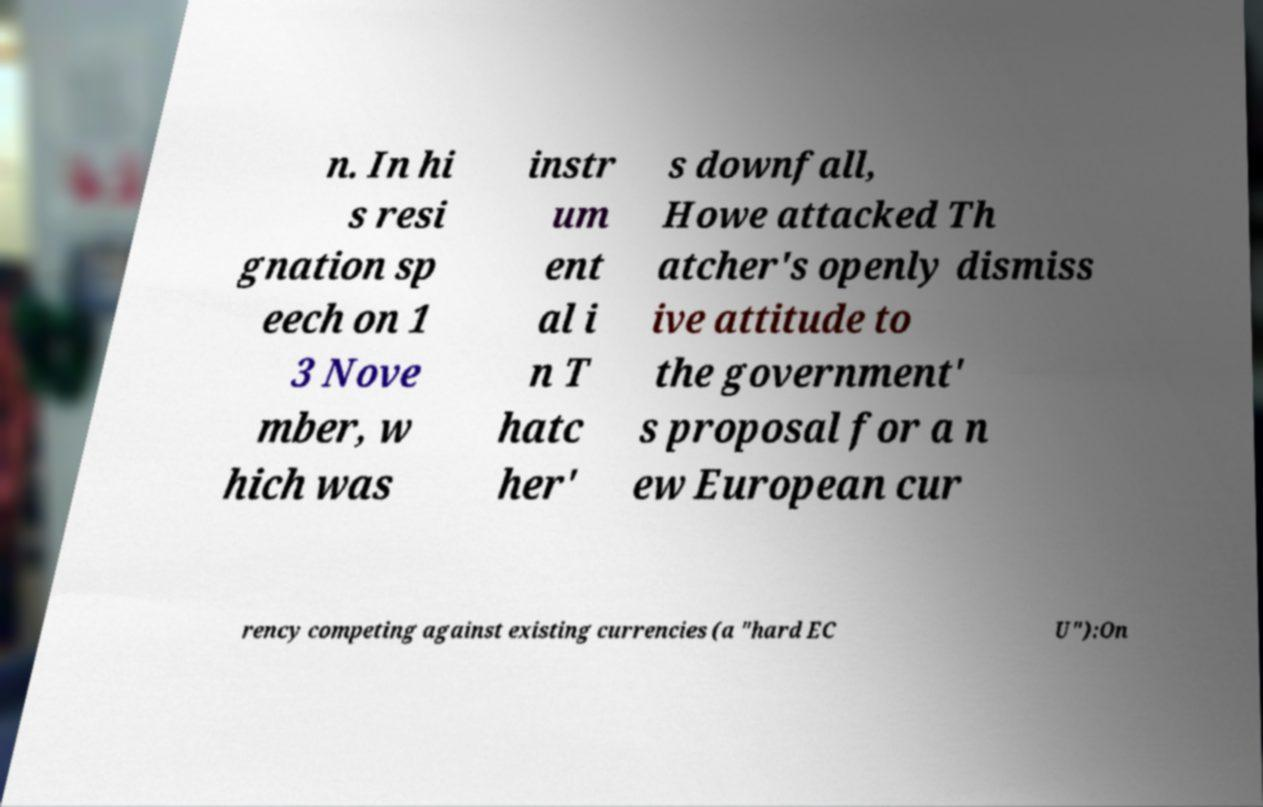For documentation purposes, I need the text within this image transcribed. Could you provide that? n. In hi s resi gnation sp eech on 1 3 Nove mber, w hich was instr um ent al i n T hatc her' s downfall, Howe attacked Th atcher's openly dismiss ive attitude to the government' s proposal for a n ew European cur rency competing against existing currencies (a "hard EC U"):On 